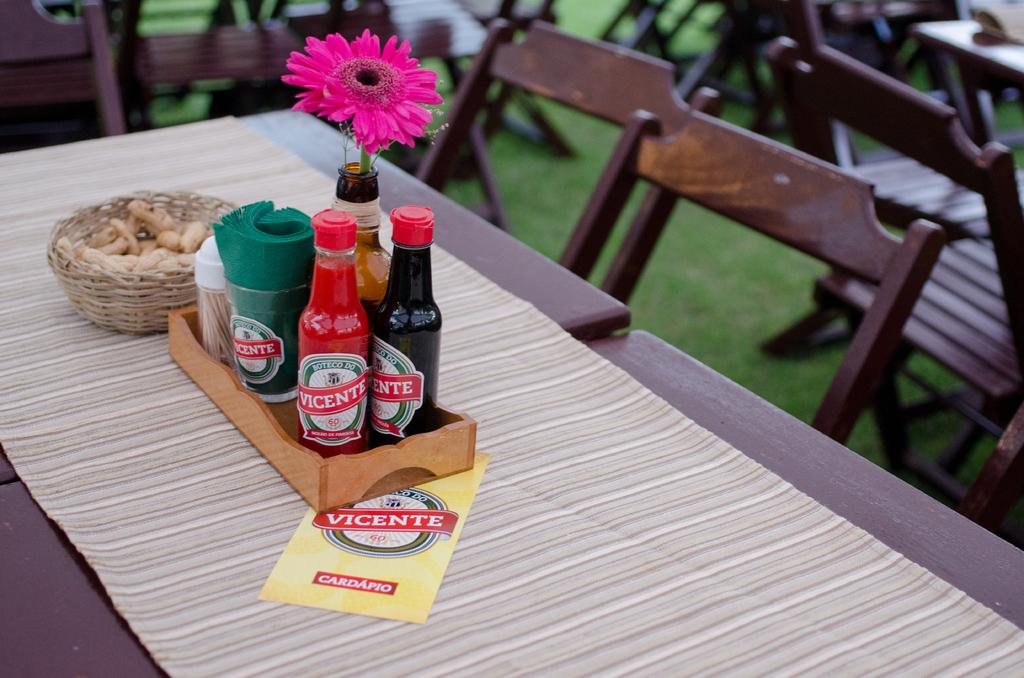<image>
Summarize the visual content of the image. Table with many sauces including one that says VICENTE on it. 